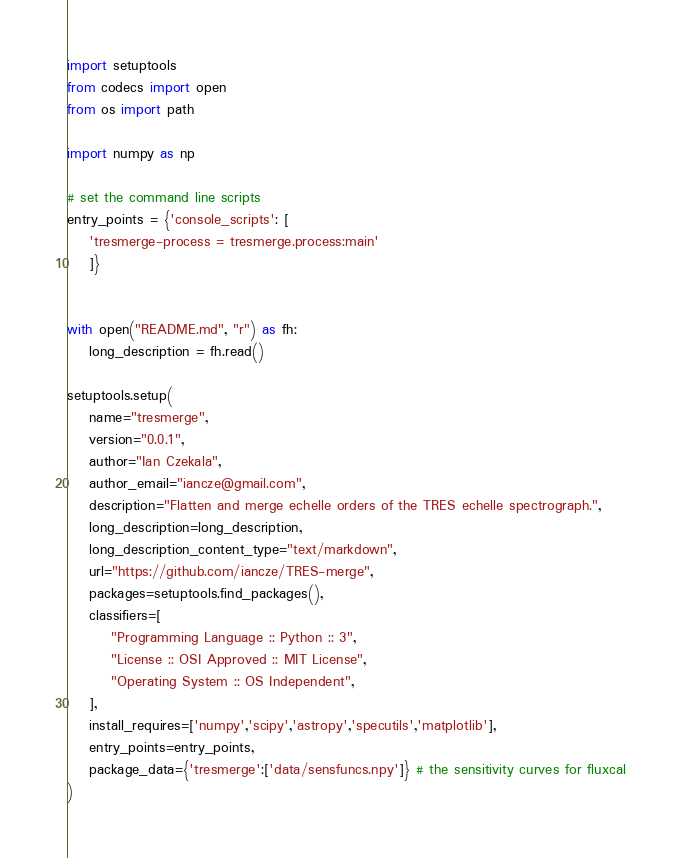<code> <loc_0><loc_0><loc_500><loc_500><_Python_>import setuptools
from codecs import open
from os import path

import numpy as np

# set the command line scripts
entry_points = {'console_scripts': [
    'tresmerge-process = tresmerge.process:main'
    ]}


with open("README.md", "r") as fh:
    long_description = fh.read()

setuptools.setup(
    name="tresmerge",
    version="0.0.1",
    author="Ian Czekala",
    author_email="iancze@gmail.com",
    description="Flatten and merge echelle orders of the TRES echelle spectrograph.",
    long_description=long_description,
    long_description_content_type="text/markdown",
    url="https://github.com/iancze/TRES-merge",
    packages=setuptools.find_packages(),
    classifiers=[
        "Programming Language :: Python :: 3",
        "License :: OSI Approved :: MIT License",
        "Operating System :: OS Independent",
    ],
    install_requires=['numpy','scipy','astropy','specutils','matplotlib'],
    entry_points=entry_points,
    package_data={'tresmerge':['data/sensfuncs.npy']} # the sensitivity curves for fluxcal
)
</code> 